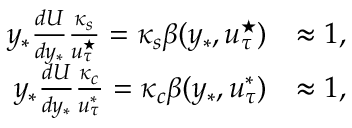Convert formula to latex. <formula><loc_0><loc_0><loc_500><loc_500>\begin{array} { r l } { y _ { * } \frac { d U } { d y _ { * } } \frac { \kappa _ { s } } { u _ { \tau } ^ { ^ { * } } } = \kappa _ { s } \beta ( y _ { * } , u _ { \tau } ^ { ^ { * } } ) } & { \approx 1 , } \\ { y _ { * } \frac { d U } { d y _ { * } } \frac { \kappa _ { c } } { u _ { \tau } ^ { * } } = \kappa _ { c } \beta ( y _ { * } , u _ { \tau } ^ { * } ) } & { \approx 1 , } \end{array}</formula> 